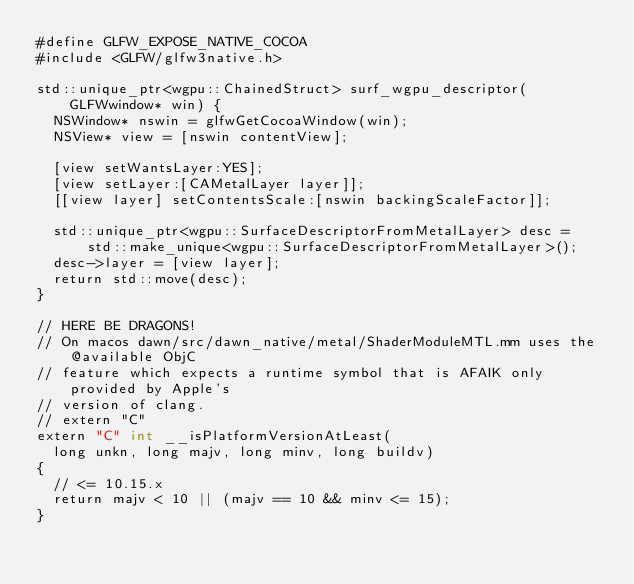<code> <loc_0><loc_0><loc_500><loc_500><_ObjectiveC_>#define GLFW_EXPOSE_NATIVE_COCOA
#include <GLFW/glfw3native.h>

std::unique_ptr<wgpu::ChainedStruct> surf_wgpu_descriptor(GLFWwindow* win) {
  NSWindow* nswin = glfwGetCocoaWindow(win);
  NSView* view = [nswin contentView];

  [view setWantsLayer:YES];
  [view setLayer:[CAMetalLayer layer]];
  [[view layer] setContentsScale:[nswin backingScaleFactor]];

  std::unique_ptr<wgpu::SurfaceDescriptorFromMetalLayer> desc =
      std::make_unique<wgpu::SurfaceDescriptorFromMetalLayer>();
  desc->layer = [view layer];
  return std::move(desc);
}

// HERE BE DRAGONS!
// On macos dawn/src/dawn_native/metal/ShaderModuleMTL.mm uses the @available ObjC
// feature which expects a runtime symbol that is AFAIK only provided by Apple's
// version of clang.
// extern "C"
extern "C" int __isPlatformVersionAtLeast(
  long unkn, long majv, long minv, long buildv)
{
  // <= 10.15.x
  return majv < 10 || (majv == 10 && minv <= 15);
}
</code> 